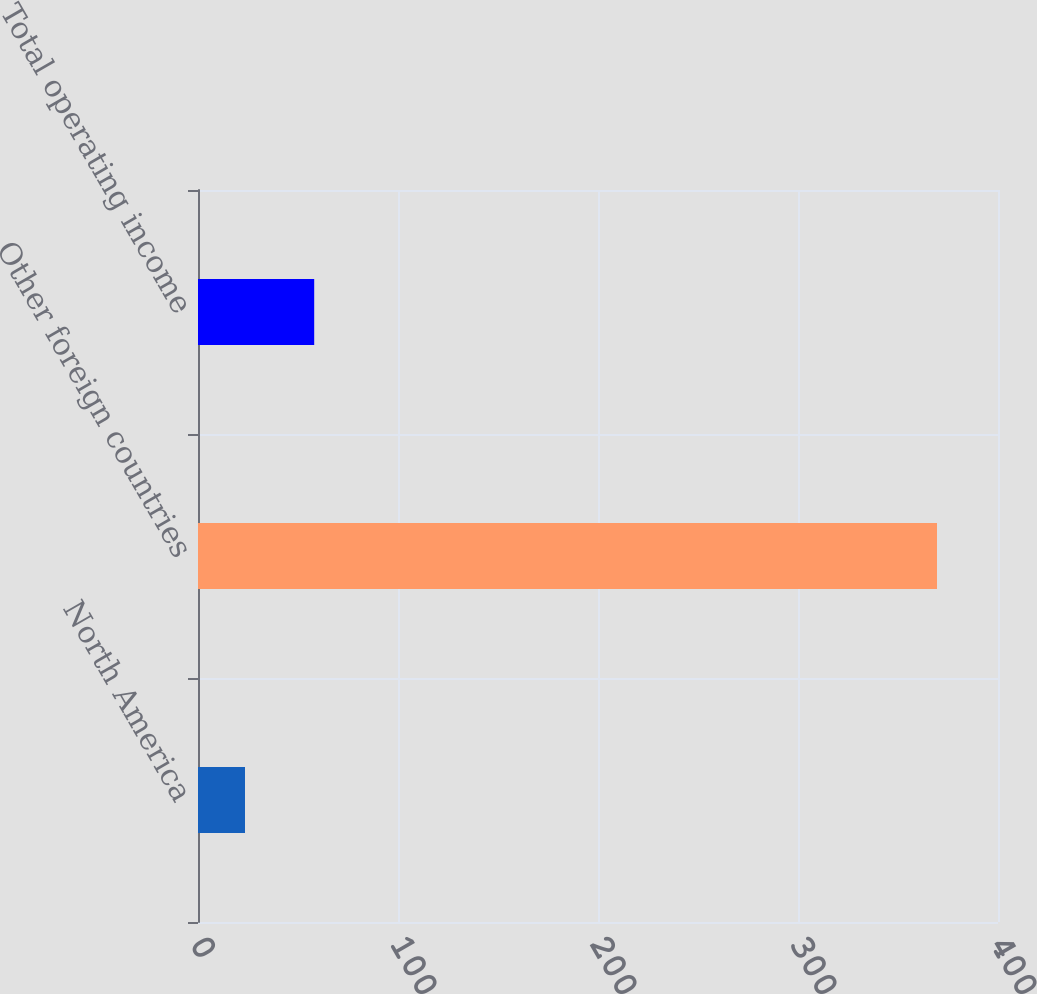Convert chart to OTSL. <chart><loc_0><loc_0><loc_500><loc_500><bar_chart><fcel>North America<fcel>Other foreign countries<fcel>Total operating income<nl><fcel>23.5<fcel>369.5<fcel>58.1<nl></chart> 